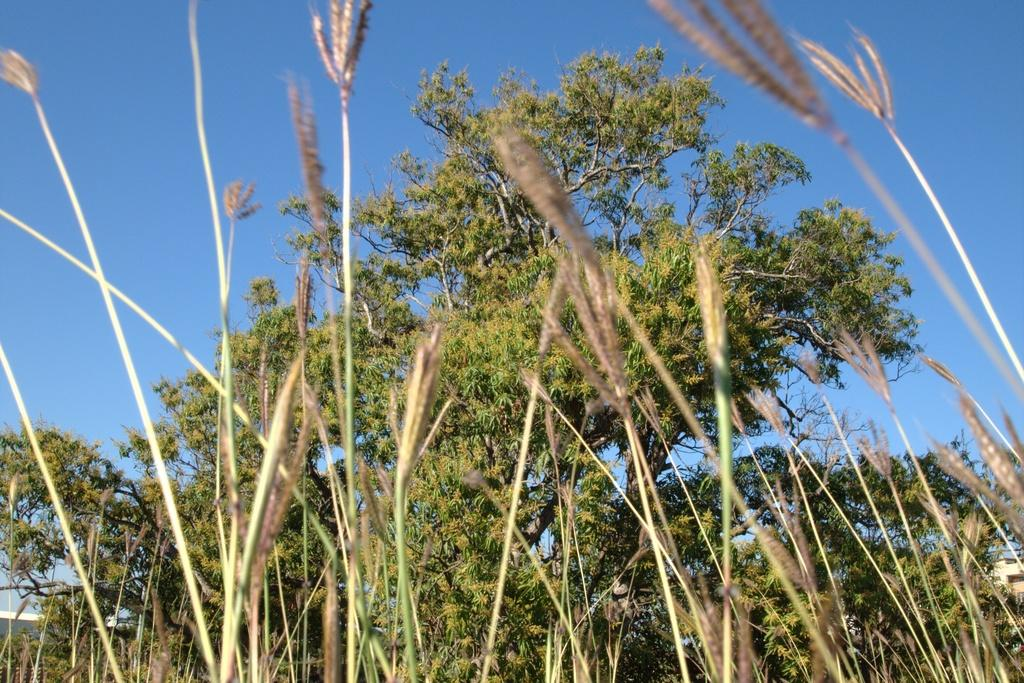What type of vegetation is present in the image? There is grass in the image. Are there any other plants visible in the image? Yes, there are trees in the image. What can be seen in the background of the image? The sky is visible in the background of the image. What type of songs can be heard playing in the background of the image? There are no songs or sounds present in the image, as it is a still image. 